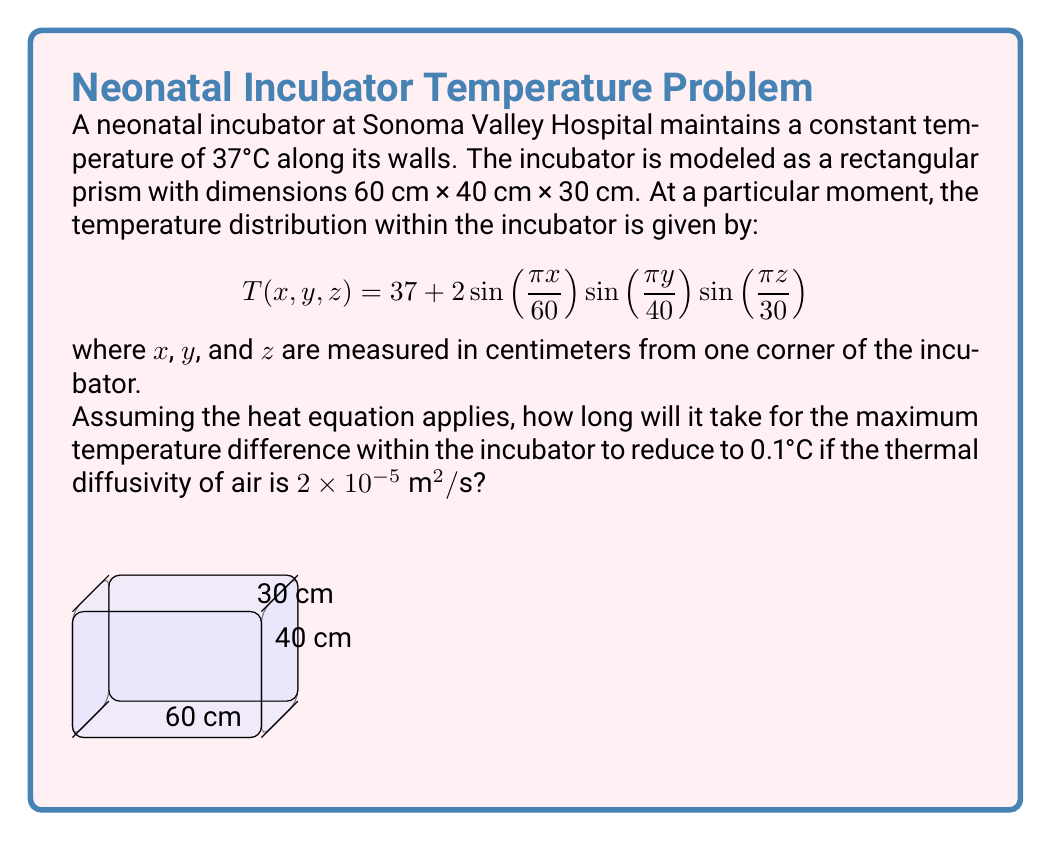What is the answer to this math problem? Let's approach this step-by-step:

1) The heat equation in 3D is given by:

   $$\frac{\partial T}{\partial t} = \alpha(\frac{\partial^2 T}{\partial x^2} + \frac{\partial^2 T}{\partial y^2} + \frac{\partial^2 T}{\partial z^2})$$

   where $\alpha$ is the thermal diffusivity.

2) The solution to this equation with the given boundary conditions is of the form:

   $$T(x,y,z,t) = 37 + 2e^{-\lambda t}\sin(\frac{\pi x}{60})\sin(\frac{\pi y}{40})\sin(\frac{\pi z}{30})$$

3) Substituting this into the heat equation, we get:

   $$-2\lambda e^{-\lambda t}\sin(\frac{\pi x}{60})\sin(\frac{\pi y}{40})\sin(\frac{\pi z}{30}) = $$
   $$\alpha(-2)(\frac{\pi^2}{60^2} + \frac{\pi^2}{40^2} + \frac{\pi^2}{30^2})e^{-\lambda t}\sin(\frac{\pi x}{60})\sin(\frac{\pi y}{40})\sin(\frac{\pi z}{30})$$

4) Simplifying:

   $$\lambda = \alpha\pi^2(\frac{1}{60^2} + \frac{1}{40^2} + \frac{1}{30^2})$$

5) Substituting $\alpha = 2 \times 10^{-5} \text{ m}^2/\text{s} = 0.0002 \text{ m}^2/\text{s}$:

   $$\lambda = 0.0002 \times \pi^2 \times (\frac{1}{0.6^2} + \frac{1}{0.4^2} + \frac{1}{0.3^2}) = 0.002738 \text{ s}^{-1}$$

6) The maximum temperature difference at time $t$ is $4e^{-\lambda t}$. We want this to be 0.1°C:

   $$4e^{-\lambda t} = 0.1$$

7) Solving for $t$:

   $$t = -\frac{1}{\lambda}\ln(\frac{0.1}{4}) = -\frac{1}{0.002738}\ln(0.025) = 1346 \text{ seconds}$$
Answer: 1346 seconds (or approximately 22.4 minutes) 